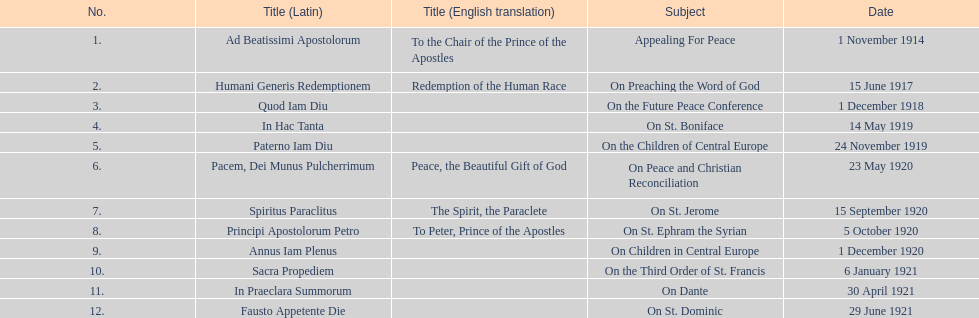What is the initial english translation displayed on the table? To the Chair of the Prince of the Apostles. 